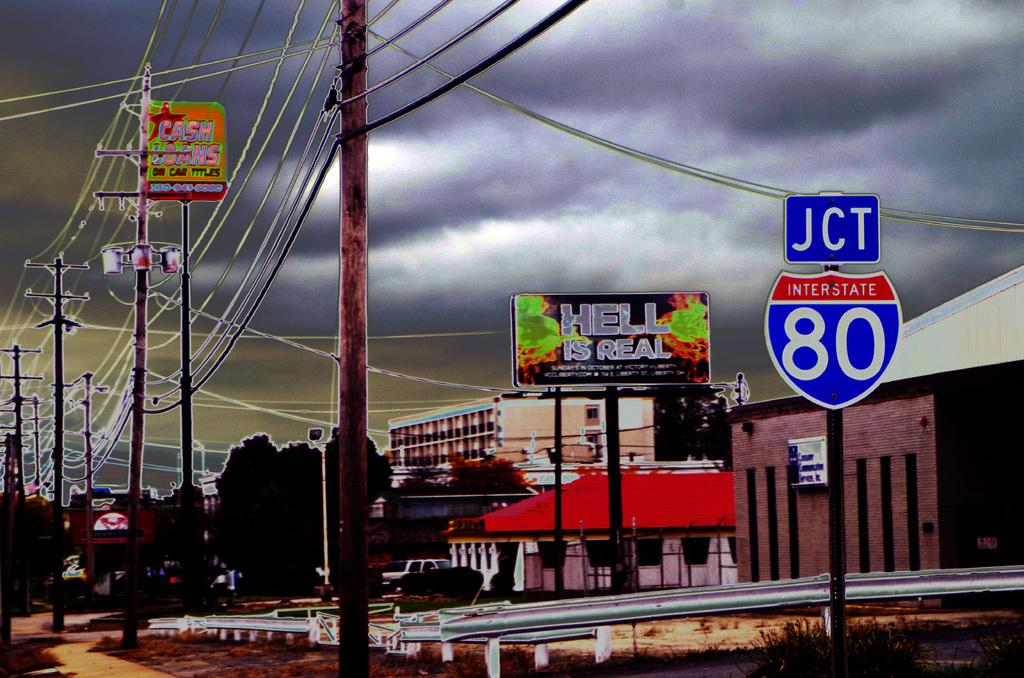<image>
Give a short and clear explanation of the subsequent image. A picture of a small city with a sign that reads JCT INTERSTATE 80. 